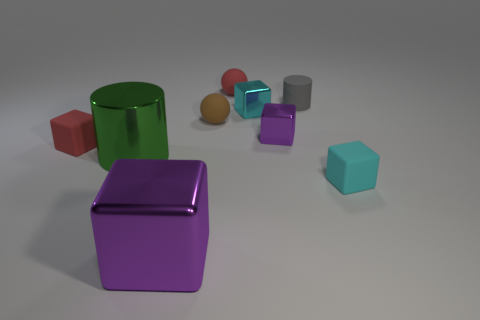Subtract all red cubes. How many cubes are left? 4 Subtract all tiny red matte blocks. How many blocks are left? 4 Subtract all yellow cubes. Subtract all yellow spheres. How many cubes are left? 5 Add 1 tiny cyan rubber cylinders. How many objects exist? 10 Subtract all balls. How many objects are left? 7 Subtract 0 purple cylinders. How many objects are left? 9 Subtract all big blue things. Subtract all red rubber blocks. How many objects are left? 8 Add 3 tiny cyan matte objects. How many tiny cyan matte objects are left? 4 Add 5 shiny cylinders. How many shiny cylinders exist? 6 